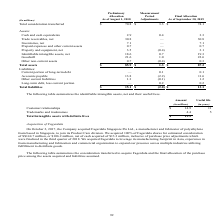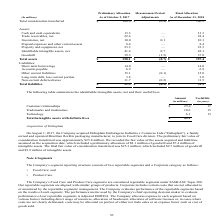According to Sealed Air Corporation's financial document, What was the company acquired in 2017? Fagerdala Singapore Pte Ltd. The document states: "On October 2, 2017, the Company acquired Fagerdala Singapore Pte Ltd., a manufacturer and fabricator of polyethylene foam based in Singapore, to join ..." Also, Why was the company acquired in 2017? to leverage its manufacturing footprint in Asia, experience in foam manufacturing and fabrication and commercial organization to expand our presence across multiple industries utilizing fulfillment to distribute goods.. The document states: "n the third quarter of 2018. We acquired Fagerdala to leverage its manufacturing footprint in Asia, experience in foam manufacturing and fabrication a..." Also, What does the table represent? Based on the financial document, the answer is summarizes the consideration transferred to acquire Fagerdala and the final allocation of the purchase price among the assets acquired and liabilities assumed. price among the assets acquired and liabilities assumed.. Also, can you calculate: What is the value of 1 USD to SGD at time of calculation? Based on the calculation: 144.7/106.2, the result is 1.36. This is based on the information: "r estimated consideration of S$144.7 million, or $106.2 million, net of cash acquired of $13.3 million, inclusive of purchase price adjustments which were Fagerdala shares for estimated consideration ..." The key data points involved are: 106.2, 144.7. Also, can you calculate: What is the asset to liability ratio As of December 31, 2018?  Based on the calculation: 51.2/157.4, the result is 32.53 (percentage). This is based on the information: "Total liabilities $ 51.5 $ (0.3) $ 51.2 Total assets $ 158.1 $ (0.7) $ 157.4..." The key data points involved are: 157.4, 51.2. Also, can you calculate: What is the difference between the asset to liability ratio As of December 31, 2018 vs. As of October 2, 2017? To answer this question, I need to perform calculations using the financial data. The calculation is: (51.2/157.4)-(51.5/158.1), which equals -0.05 (percentage). This is based on the information: "Total liabilities $ 51.5 $ (0.3) $ 51.2 Total liabilities $ 51.5 $ (0.3) $ 51.2 Total assets $ 158.1 $ (0.7) $ 157.4 Total assets $ 158.1 $ (0.7) $ 157.4..." The key data points involved are: 157.4, 158.1, 51.2. 